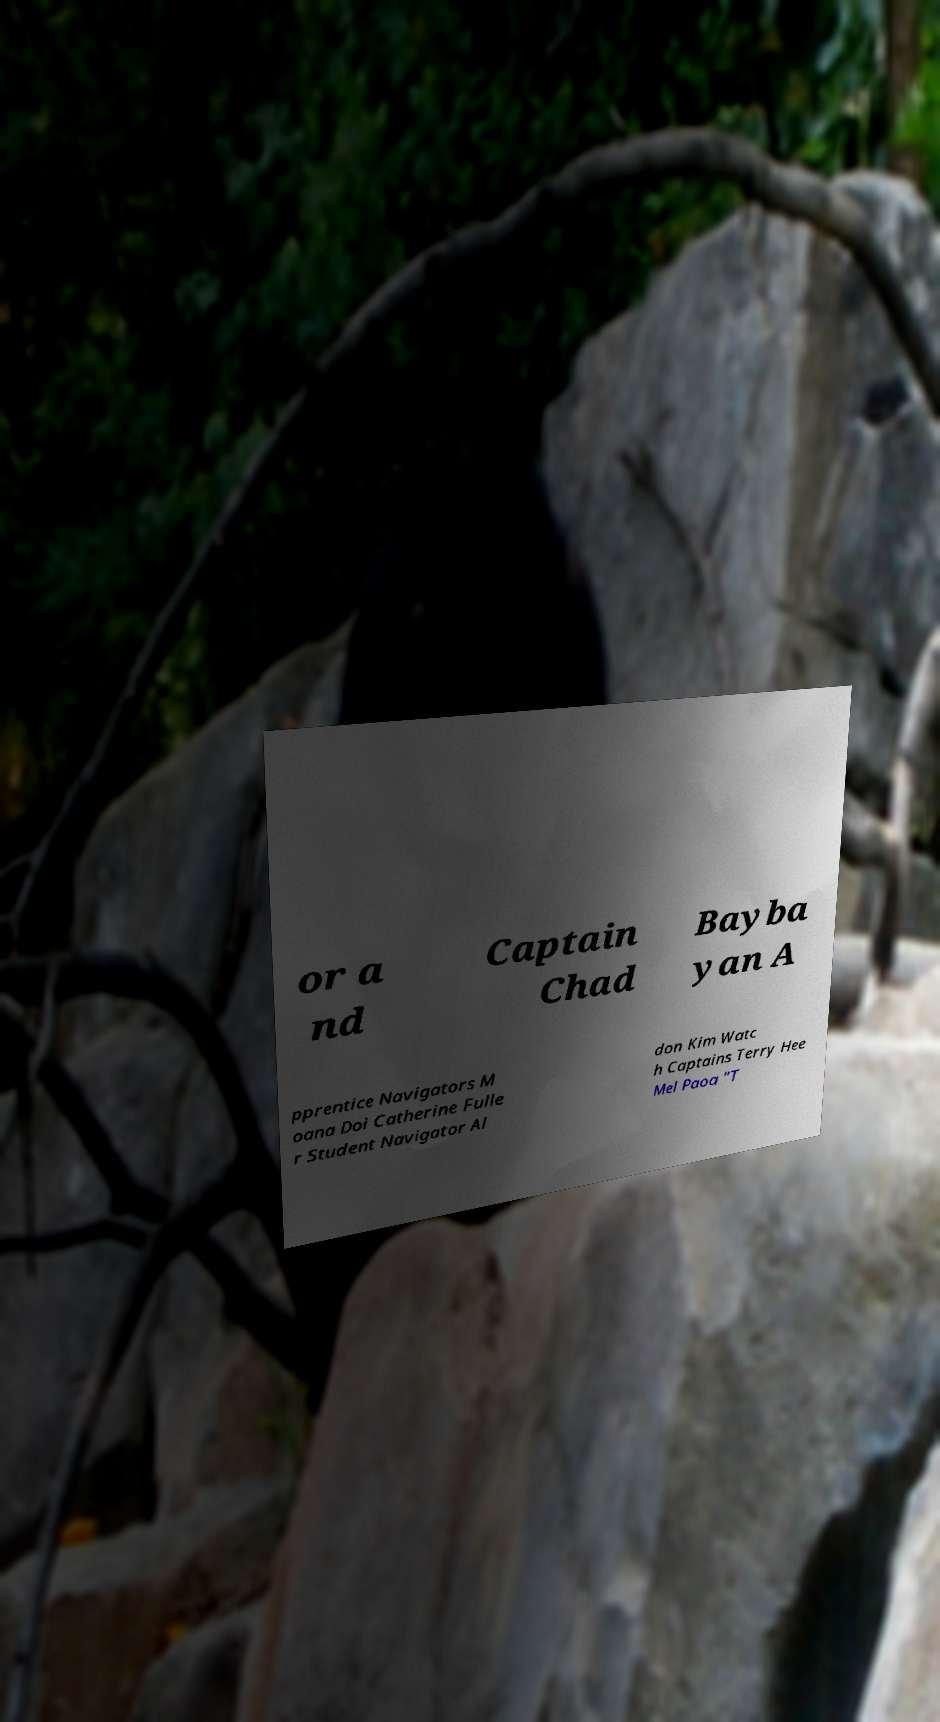Could you assist in decoding the text presented in this image and type it out clearly? or a nd Captain Chad Bayba yan A pprentice Navigators M oana Doi Catherine Fulle r Student Navigator Al don Kim Watc h Captains Terry Hee Mel Paoa "T 